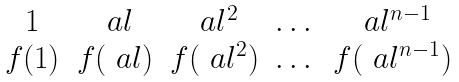<formula> <loc_0><loc_0><loc_500><loc_500>\begin{matrix} 1 & \ a l & \ a l ^ { 2 } & \dots & \ a l ^ { n - 1 } \\ f ( 1 ) & f ( \ a l ) & f ( \ a l ^ { 2 } ) & \dots & f ( \ a l ^ { n - 1 } ) \end{matrix}</formula> 